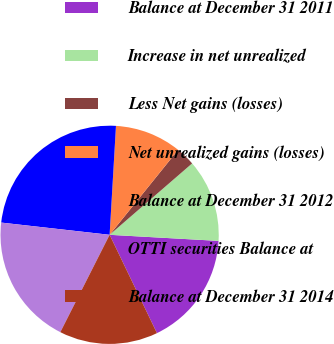<chart> <loc_0><loc_0><loc_500><loc_500><pie_chart><fcel>Balance at December 31 2011<fcel>Increase in net unrealized<fcel>Less Net gains (losses)<fcel>Net unrealized gains (losses)<fcel>Balance at December 31 2012<fcel>OTTI securities Balance at<fcel>Balance at December 31 2014<nl><fcel>16.97%<fcel>12.24%<fcel>2.85%<fcel>9.87%<fcel>24.14%<fcel>19.33%<fcel>14.6%<nl></chart> 